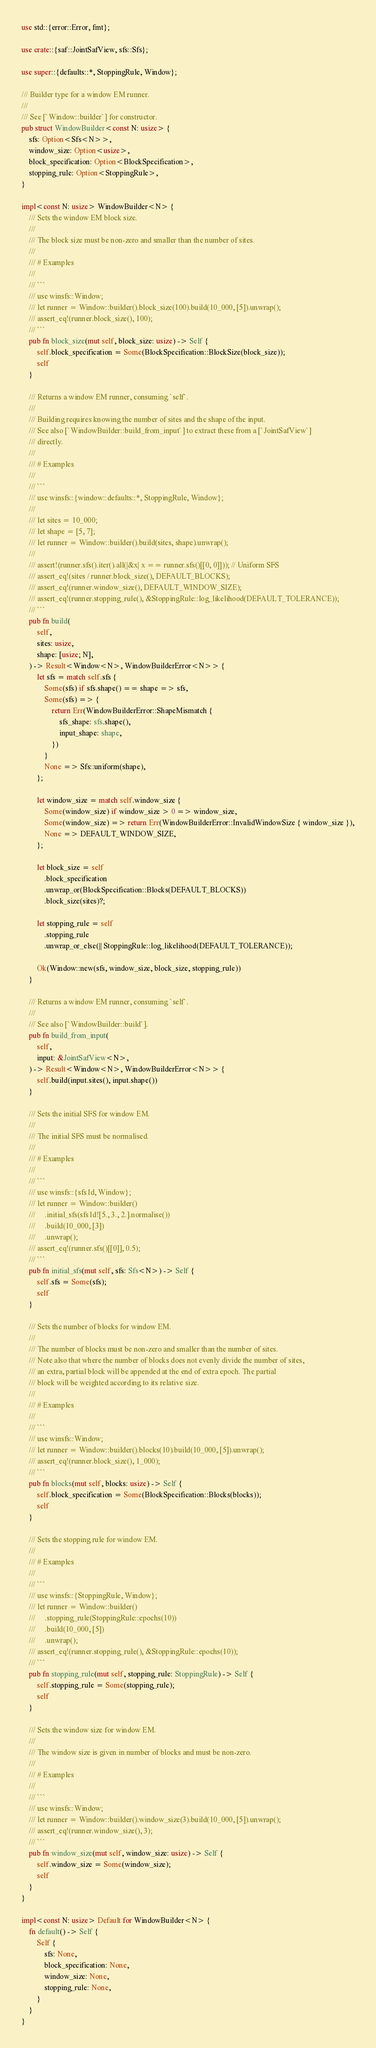Convert code to text. <code><loc_0><loc_0><loc_500><loc_500><_Rust_>use std::{error::Error, fmt};

use crate::{saf::JointSafView, sfs::Sfs};

use super::{defaults::*, StoppingRule, Window};

/// Builder type for a window EM runner.
///
/// See [`Window::builder`] for constructor.
pub struct WindowBuilder<const N: usize> {
    sfs: Option<Sfs<N>>,
    window_size: Option<usize>,
    block_specification: Option<BlockSpecification>,
    stopping_rule: Option<StoppingRule>,
}

impl<const N: usize> WindowBuilder<N> {
    /// Sets the window EM block size.
    ///
    /// The block size must be non-zero and smaller than the number of sites.
    ///
    /// # Examples
    ///
    /// ```
    /// use winsfs::Window;
    /// let runner = Window::builder().block_size(100).build(10_000, [5]).unwrap();
    /// assert_eq!(runner.block_size(), 100);
    /// ```
    pub fn block_size(mut self, block_size: usize) -> Self {
        self.block_specification = Some(BlockSpecification::BlockSize(block_size));
        self
    }

    /// Returns a window EM runner, consuming `self`.
    ///
    /// Building requires knowing the number of sites and the shape of the input.
    /// See also [`WindowBuilder::build_from_input`] to extract these from a [`JointSafView`]
    /// directly.
    ///
    /// # Examples
    ///
    /// ```
    /// use winsfs::{window::defaults::*, StoppingRule, Window};
    ///
    /// let sites = 10_000;
    /// let shape = [5, 7];
    /// let runner = Window::builder().build(sites, shape).unwrap();
    ///
    /// assert!(runner.sfs().iter().all(|&x| x == runner.sfs()[[0, 0]])); // Uniform SFS
    /// assert_eq!(sites / runner.block_size(), DEFAULT_BLOCKS);
    /// assert_eq!(runner.window_size(), DEFAULT_WINDOW_SIZE);
    /// assert_eq!(runner.stopping_rule(), &StoppingRule::log_likelihood(DEFAULT_TOLERANCE));
    /// ```
    pub fn build(
        self,
        sites: usize,
        shape: [usize; N],
    ) -> Result<Window<N>, WindowBuilderError<N>> {
        let sfs = match self.sfs {
            Some(sfs) if sfs.shape() == shape => sfs,
            Some(sfs) => {
                return Err(WindowBuilderError::ShapeMismatch {
                    sfs_shape: sfs.shape(),
                    input_shape: shape,
                })
            }
            None => Sfs::uniform(shape),
        };

        let window_size = match self.window_size {
            Some(window_size) if window_size > 0 => window_size,
            Some(window_size) => return Err(WindowBuilderError::InvalidWindowSize { window_size }),
            None => DEFAULT_WINDOW_SIZE,
        };

        let block_size = self
            .block_specification
            .unwrap_or(BlockSpecification::Blocks(DEFAULT_BLOCKS))
            .block_size(sites)?;

        let stopping_rule = self
            .stopping_rule
            .unwrap_or_else(|| StoppingRule::log_likelihood(DEFAULT_TOLERANCE));

        Ok(Window::new(sfs, window_size, block_size, stopping_rule))
    }

    /// Returns a window EM runner, consuming `self`.
    ///
    /// See also [`WindowBuilder::build`].
    pub fn build_from_input(
        self,
        input: &JointSafView<N>,
    ) -> Result<Window<N>, WindowBuilderError<N>> {
        self.build(input.sites(), input.shape())
    }

    /// Sets the initial SFS for window EM.
    ///
    /// The initial SFS must be normalised.
    ///
    /// # Examples
    ///
    /// ```
    /// use winsfs::{sfs1d, Window};
    /// let runner = Window::builder()
    ///     .initial_sfs(sfs1d![5., 3., 2.].normalise())
    ///     .build(10_000, [3])
    ///     .unwrap();
    /// assert_eq!(runner.sfs()[[0]], 0.5);
    /// ```
    pub fn initial_sfs(mut self, sfs: Sfs<N>) -> Self {
        self.sfs = Some(sfs);
        self
    }

    /// Sets the number of blocks for window EM.
    ///
    /// The number of blocks must be non-zero and smaller than the number of sites.
    /// Note also that where the number of blocks does not evenly divide the number of sites,
    /// an extra, partial block will be appended at the end of extra epoch. The partial
    /// block will be weighted according to its relative size.
    ///
    /// # Examples
    ///
    /// ```
    /// use winsfs::Window;
    /// let runner = Window::builder().blocks(10).build(10_000, [5]).unwrap();
    /// assert_eq!(runner.block_size(), 1_000);
    /// ```
    pub fn blocks(mut self, blocks: usize) -> Self {
        self.block_specification = Some(BlockSpecification::Blocks(blocks));
        self
    }

    /// Sets the stopping rule for window EM.
    ///
    /// # Examples
    ///
    /// ```
    /// use winsfs::{StoppingRule, Window};
    /// let runner = Window::builder()
    ///     .stopping_rule(StoppingRule::epochs(10))
    ///     .build(10_000, [5])
    ///     .unwrap();
    /// assert_eq!(runner.stopping_rule(), &StoppingRule::epochs(10));
    /// ```
    pub fn stopping_rule(mut self, stopping_rule: StoppingRule) -> Self {
        self.stopping_rule = Some(stopping_rule);
        self
    }

    /// Sets the window size for window EM.
    ///
    /// The window size is given in number of blocks and must be non-zero.
    ///
    /// # Examples
    ///
    /// ```
    /// use winsfs::Window;
    /// let runner = Window::builder().window_size(3).build(10_000, [5]).unwrap();
    /// assert_eq!(runner.window_size(), 3);
    /// ```
    pub fn window_size(mut self, window_size: usize) -> Self {
        self.window_size = Some(window_size);
        self
    }
}

impl<const N: usize> Default for WindowBuilder<N> {
    fn default() -> Self {
        Self {
            sfs: None,
            block_specification: None,
            window_size: None,
            stopping_rule: None,
        }
    }
}
</code> 